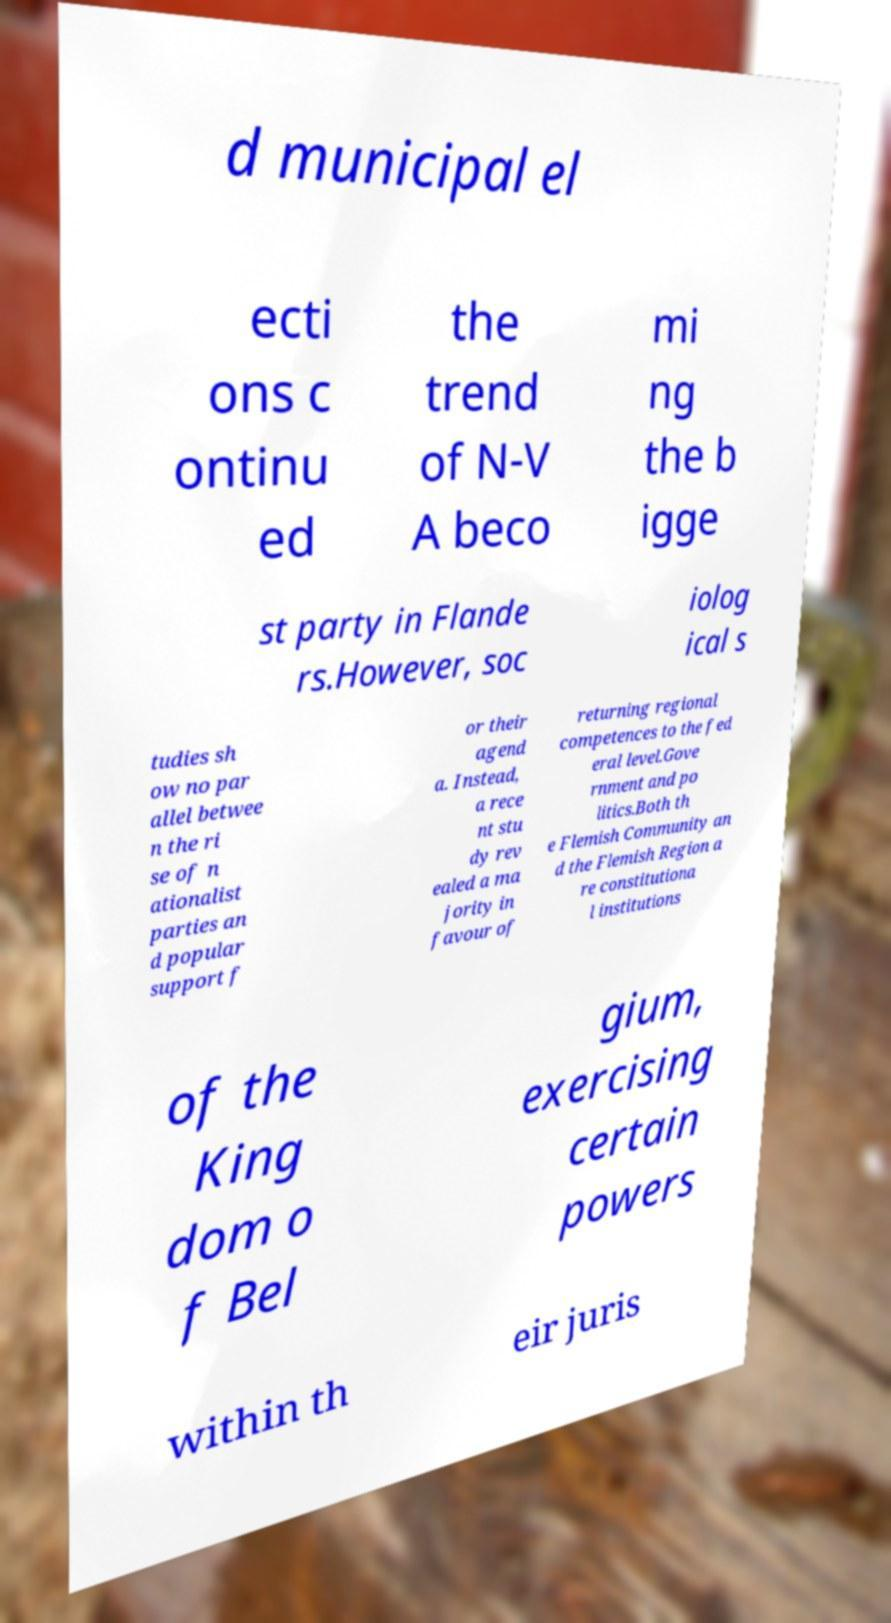Could you extract and type out the text from this image? d municipal el ecti ons c ontinu ed the trend of N-V A beco mi ng the b igge st party in Flande rs.However, soc iolog ical s tudies sh ow no par allel betwee n the ri se of n ationalist parties an d popular support f or their agend a. Instead, a rece nt stu dy rev ealed a ma jority in favour of returning regional competences to the fed eral level.Gove rnment and po litics.Both th e Flemish Community an d the Flemish Region a re constitutiona l institutions of the King dom o f Bel gium, exercising certain powers within th eir juris 